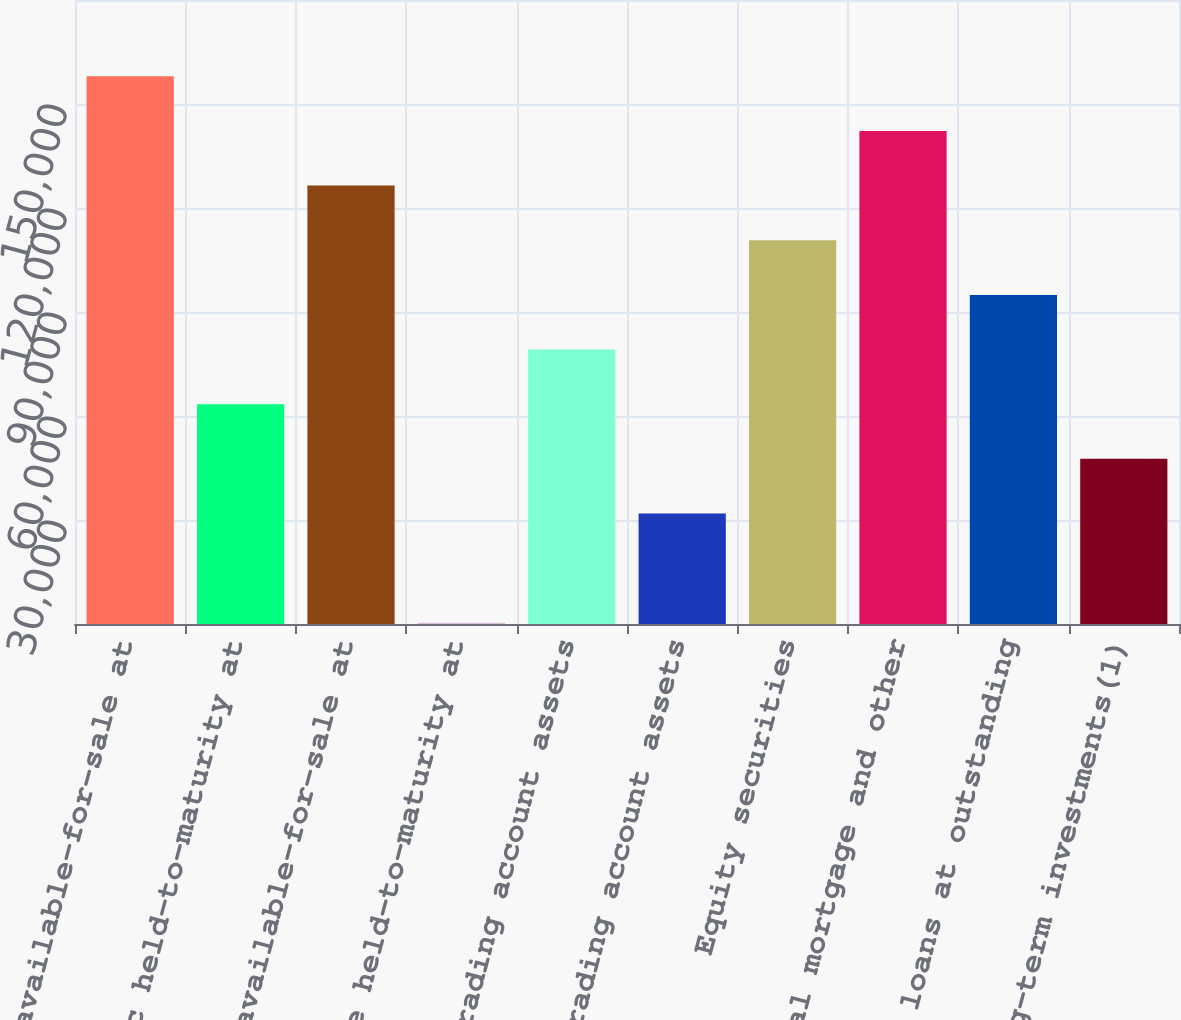Convert chart to OTSL. <chart><loc_0><loc_0><loc_500><loc_500><bar_chart><fcel>Public available-for-sale at<fcel>Public held-to-maturity at<fcel>Private available-for-sale at<fcel>Private held-to-maturity at<fcel>Trading account assets<fcel>Other trading account assets<fcel>Equity securities<fcel>Commercial mortgage and other<fcel>Policy loans at outstanding<fcel>Other long-term investments(1)<nl><fcel>157982<fcel>63416<fcel>126460<fcel>372<fcel>79177<fcel>31894<fcel>110699<fcel>142221<fcel>94938<fcel>47655<nl></chart> 